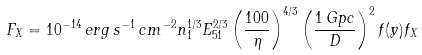Convert formula to latex. <formula><loc_0><loc_0><loc_500><loc_500>F _ { X } = 1 0 ^ { - 1 4 } \, e r g \, s ^ { - 1 } \, c m ^ { - 2 } n _ { 1 } ^ { 1 / 3 } E _ { 5 1 } ^ { 2 / 3 } \left ( \frac { 1 0 0 } { \eta } \right ) ^ { 4 / 3 } \left ( \frac { 1 \, G p c } { D } \right ) ^ { 2 } f ( y ) f _ { X }</formula> 